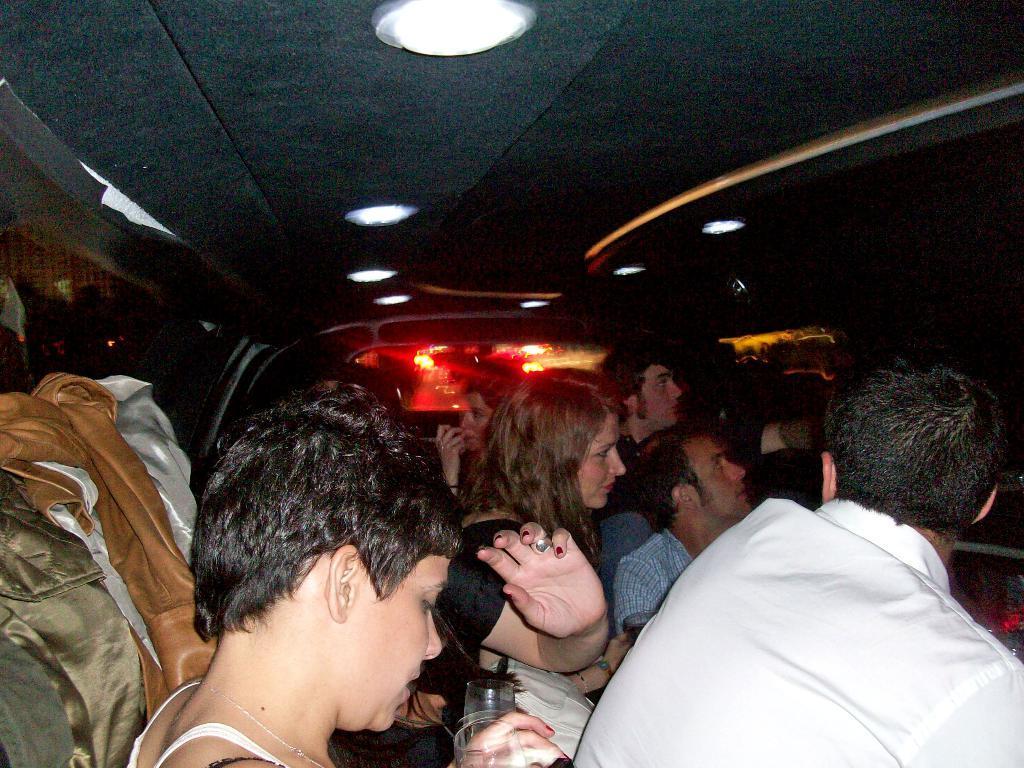Describe this image in one or two sentences. In the center of the image there are people sitting inside a car. 